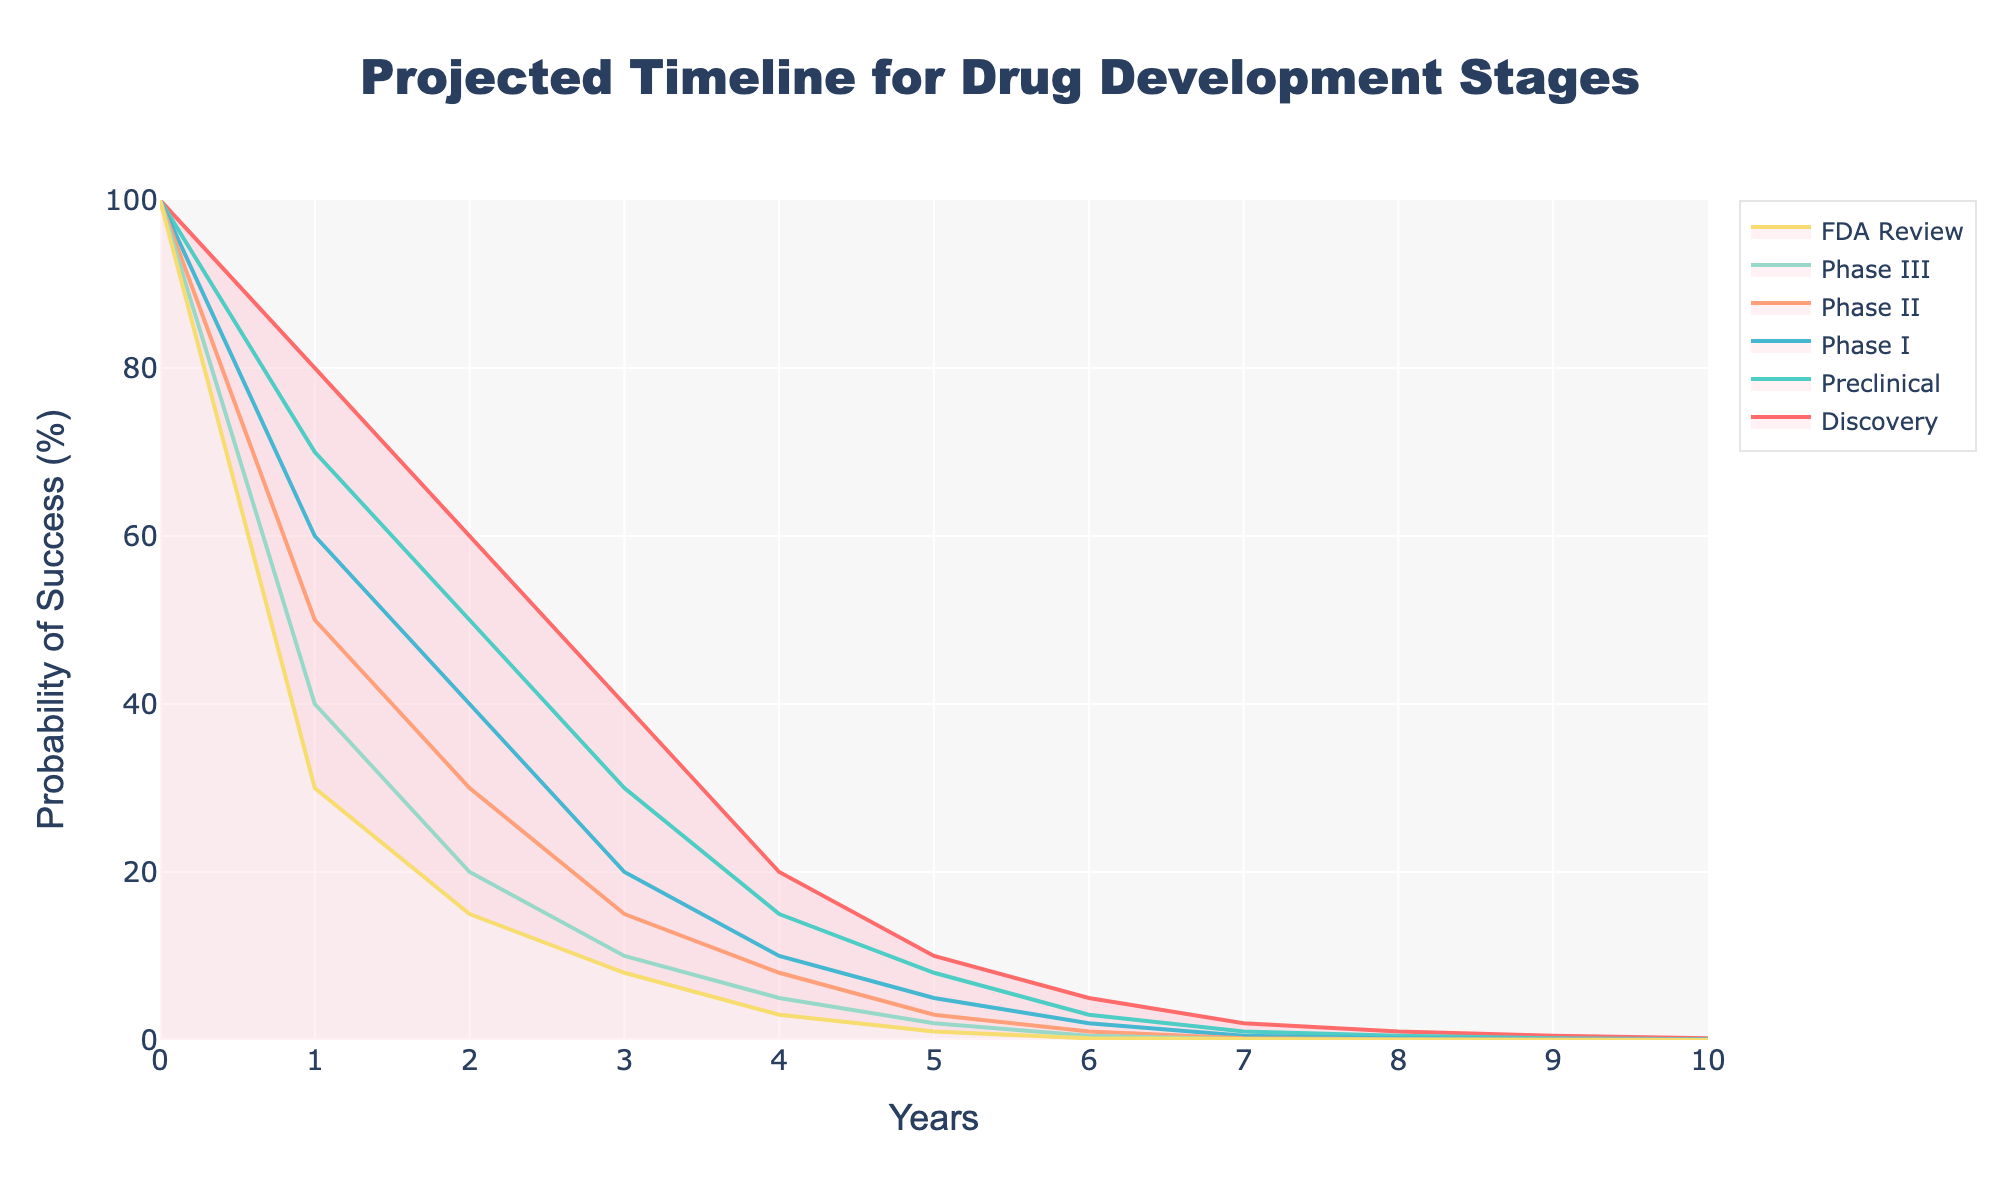What is the title of the chart? The title of the chart is displayed at the top and is usually one of the most prominent textual elements.
Answer: Projected Timeline for Drug Development Stages What does the y-axis represent? The y-axis shows what is being measured in the vertical dimension. Here, it represents the probability of success in percentage terms.
Answer: Probability of Success (%) How many years does the x-axis cover? The x-axis represents time and its range can be directly observed. It starts at year 0 and ends at year 10.
Answer: 11 years At what year does the probability of success for the FDA Review drop below 10%? You need to find the earliest point where the FDA Review's probability line falls below 10%.
Answer: Year 3 Which stage has the highest probability of success at Year 6? Compare the probabilities for all stages at Year 6 to find the highest one.
Answer: Discovery By approximately what percentage does the probability of success in the Preclinical stage decrease from Year 1 to Year 3? Subtract the probability at Year 3 from Year 1 for the Preclinical stage.
Answer: 40% (70% - 30%) In which year do the Phase III and Phase II probabilities of success approximately match? Look for the point where the values for Phase III and Phase II intersect or are closest.
Answer: Year 5 What can you infer about the success rates across the stages over time? Describe the general trend observed in the chart for all stages over the span of years.
Answer: They all decrease over time Which stage shows the steepest decline in the first two years? Check the decline steepness by comparing the percentage drop between Year 0 and Year 2 across all stages.
Answer: Phase I What is the probability of success for the Discovery stage at Year 8? Locate the data point at Year 8 within the Discovery stage line.
Answer: 1% 